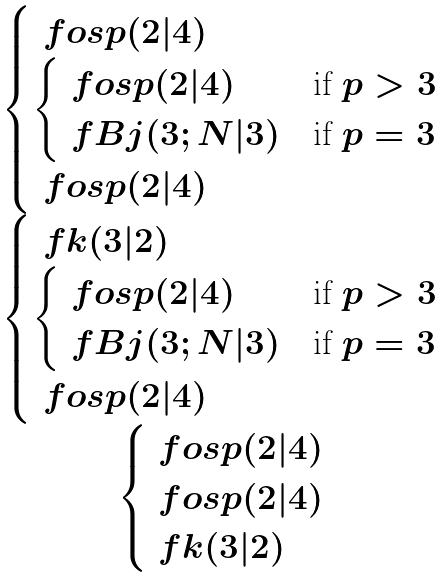Convert formula to latex. <formula><loc_0><loc_0><loc_500><loc_500>\begin{matrix} \begin{cases} \ f o s p ( 2 | 4 ) & \\ \begin{cases} \ f o s p ( 2 | 4 ) & \text {if $p>3$} \\ \ f B j ( 3 ; N | 3 ) & \text {if $p=3$} \end{cases} & \\ \ f o s p ( 2 | 4 ) & \\ \end{cases} \\ \begin{cases} \ f k ( 3 | 2 ) & \\ \begin{cases} \ f o s p ( 2 | 4 ) & \text {if $p>3$} \\ \ f B j ( 3 ; N | 3 ) & \text {if $p=3$} \end{cases} \\ \ f o s p ( 2 | 4 ) & \\ \end{cases} \\ \begin{cases} \ f o s p ( 2 | 4 ) & \\ \ f o s p ( 2 | 4 ) & \\ \ f k ( 3 | 2 ) & \\ \end{cases} \end{matrix}</formula> 